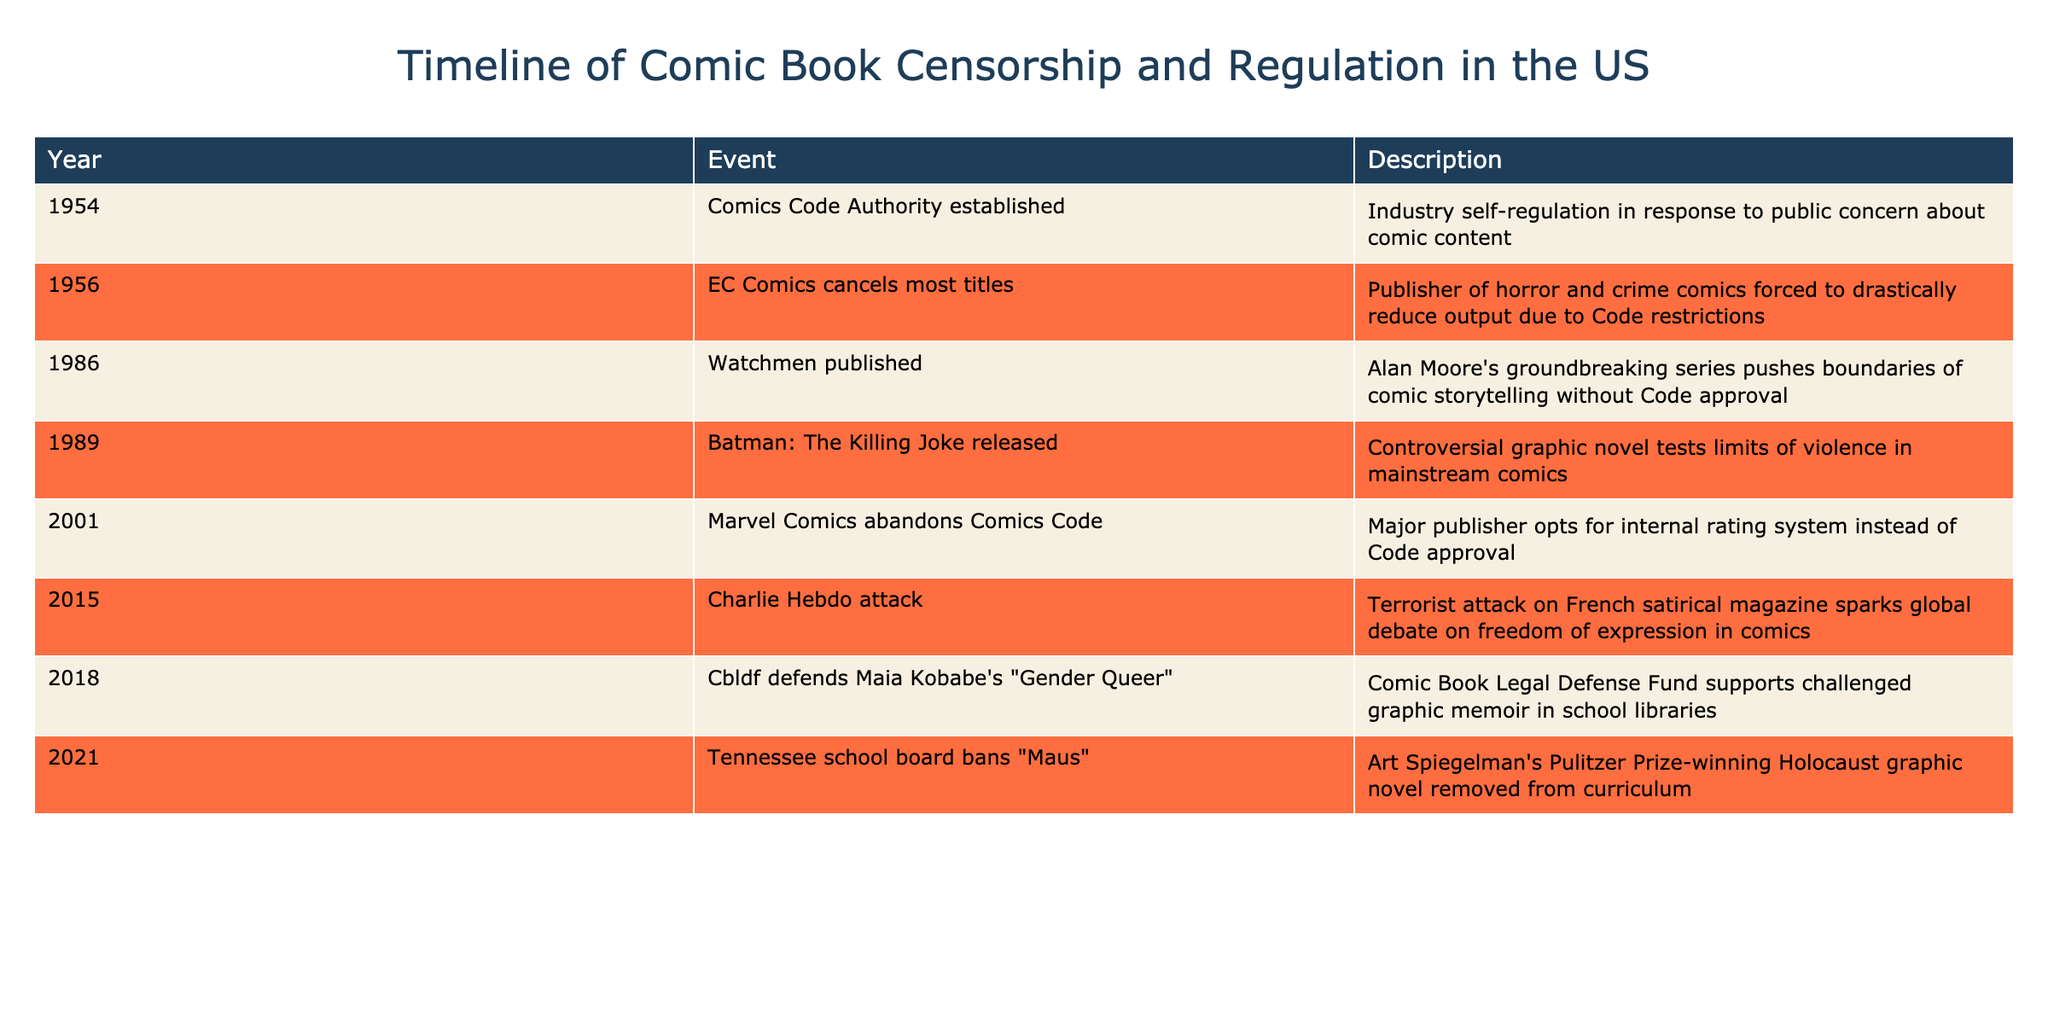What year was the Comics Code Authority established? The table explicitly lists the year when the Comics Code Authority was established, which is found in the "Year" column next to the event "Comics Code Authority established."
Answer: 1954 Which comic was released in 1989? By examining the table, the event occurring in 1989 is "Batman: The Killing Joke released," which is clearly stated alongside that year.
Answer: Batman: The Killing Joke How many events occurred before 2000? To find the number of events before 2000, I count the entries from the first row (1954) to one before (2001), which are six in total (1954, 1956, 1986, 1989, 2001, 2015).
Answer: 6 True or false: EC Comics canceled most titles in 1956 due to the Comics Code restrictions. The table indicates that the event in 1956 is "EC Comics cancels most titles," and its description confirms that it was due to Code restrictions, thus making the statement true.
Answer: True What is the time span between the establishment of the Comics Code Authority and Marvel's abandonment of it? The timeline indicates the Comics Code Authority was established in 1954 and Marvel abandoned it in 2001. Therefore, the time span is calculated as 2001 - 1954, which equals 47 years.
Answer: 47 years In what year did the international debate on freedom of expression in comics arise due to the Charlie Hebdo attack? The table shows that the event related to the Charlie Hebdo attack occurred in 2015, clearly indicated next to that year.
Answer: 2015 Which comic book related event took place last according to the timeline? Upon reviewing the timeline in reverse chronological order, the last event mentioned is "Tennessee school board bans 'Maus'," which occurred in the year 2021.
Answer: Tennessee school board bans Maus Identify two events from the table that highlight comic books testing limits of violence or content. The table lists "Batman: The Killing Joke released" in 1989 as a controversial graphic novel and "Watchmen published" in 1986 as a groundbreaking series that pushed boundaries, indicating both test content limits.
Answer: Watchmen published and Batman: The Killing Joke released How many events listed were specifically related to censorship or banning of comics? In the table, the events that pertain to censorship or banning are EC Comics canceling titles in 1956, the defense of "Gender Queer" in 2018, and the banning of "Maus" in 2021. There are three such events.
Answer: 3 